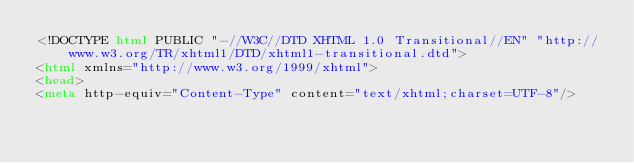<code> <loc_0><loc_0><loc_500><loc_500><_HTML_><!DOCTYPE html PUBLIC "-//W3C//DTD XHTML 1.0 Transitional//EN" "http://www.w3.org/TR/xhtml1/DTD/xhtml1-transitional.dtd">
<html xmlns="http://www.w3.org/1999/xhtml">
<head>
<meta http-equiv="Content-Type" content="text/xhtml;charset=UTF-8"/></code> 